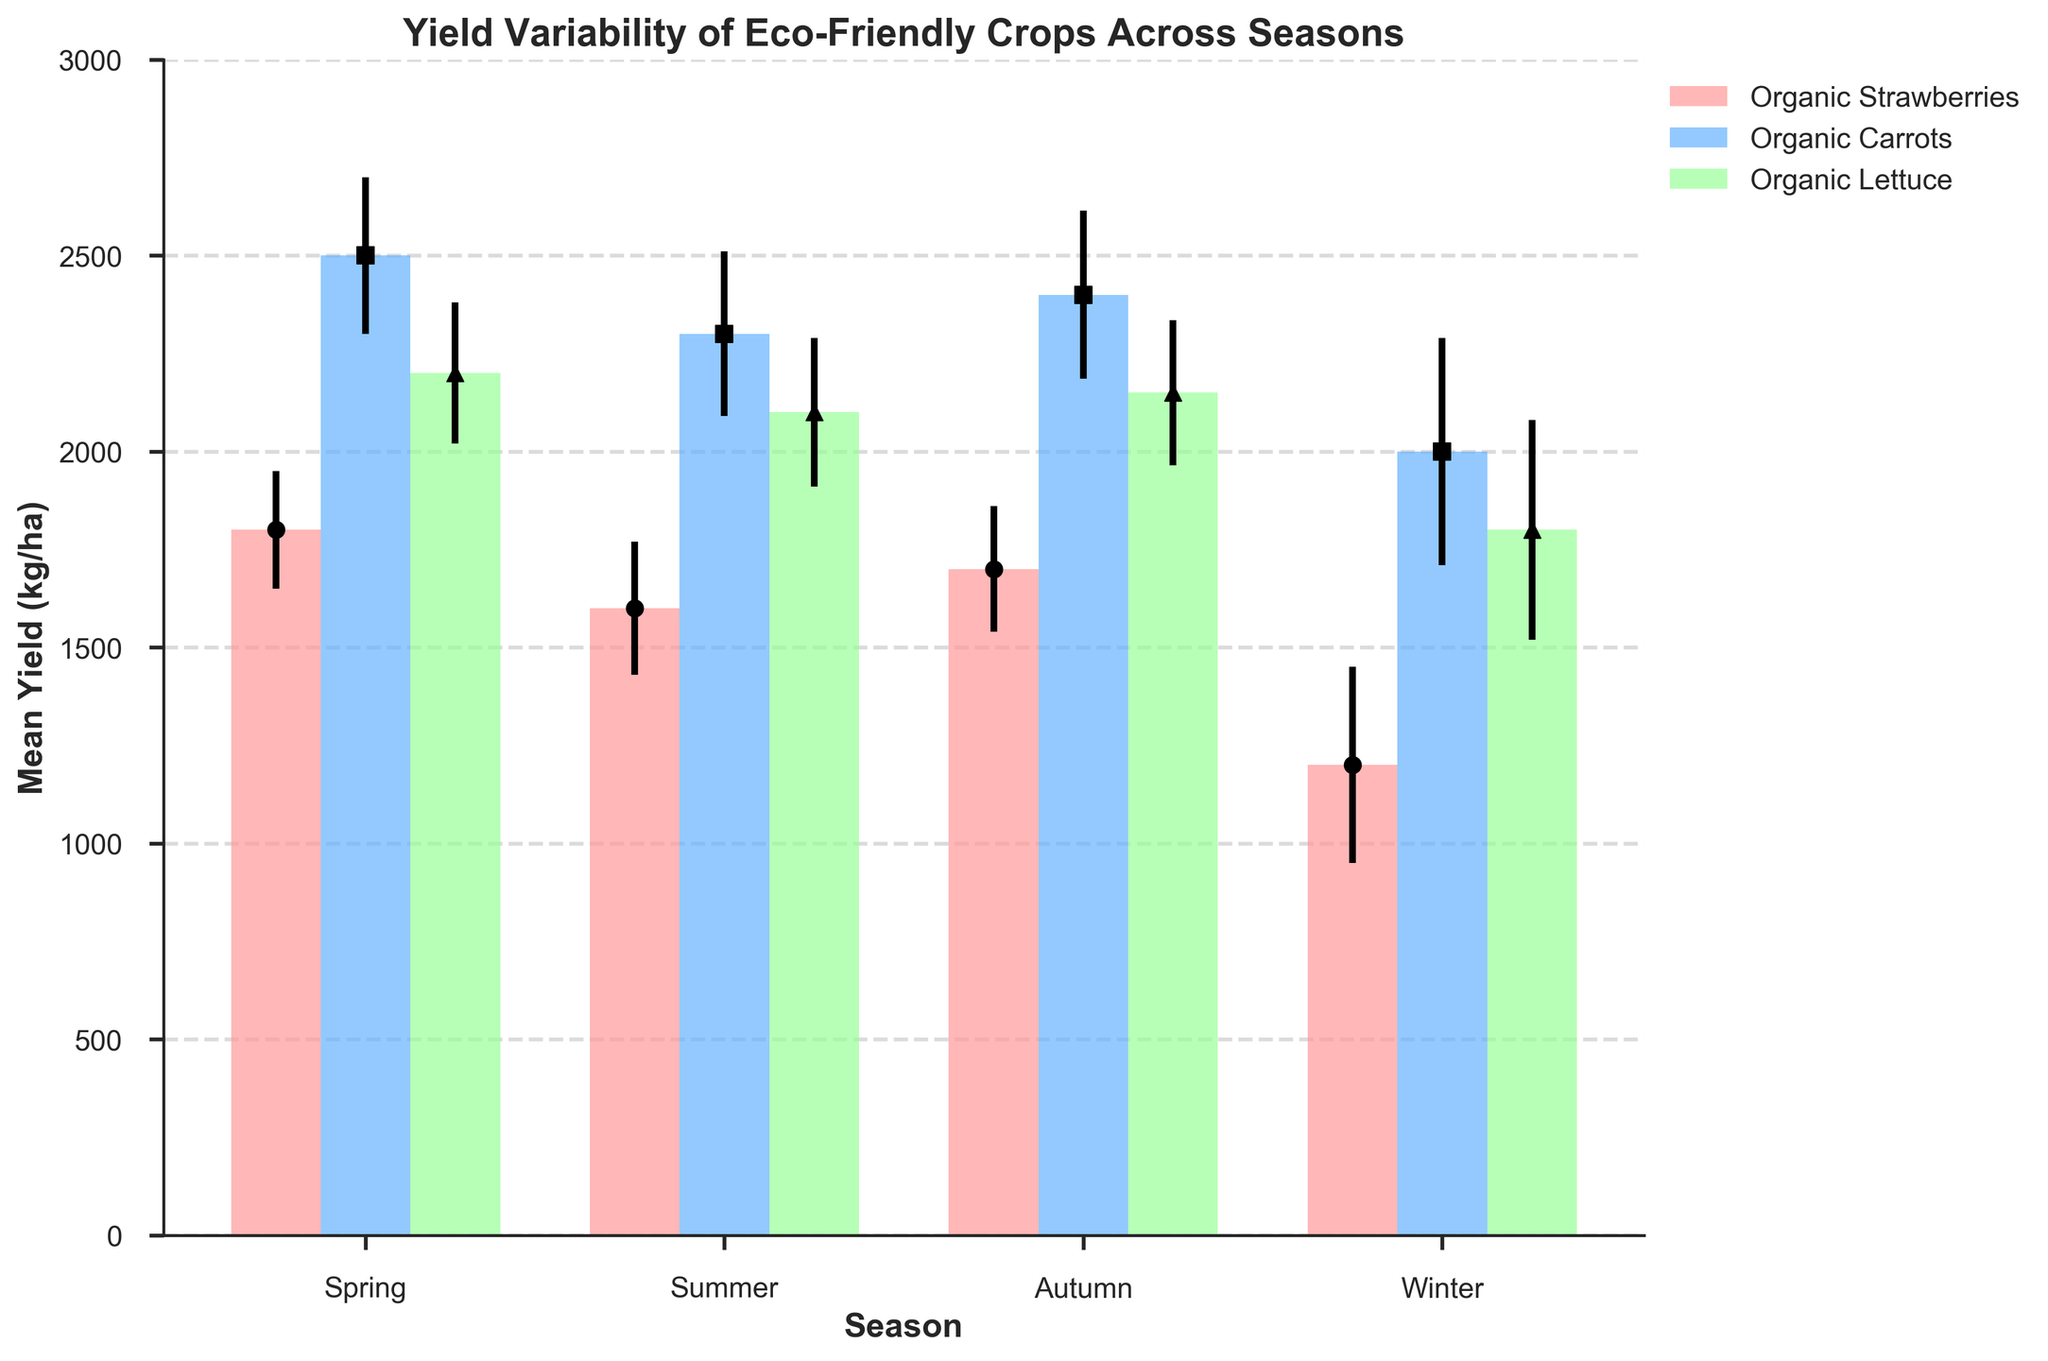What is the mean yield of Organic Strawberries in Spring? Locate the bar corresponding to Organic Strawberries for the Spring season and read the mean yield value shown on the y-axis. It is the height of the bar representing this crop in Spring.
Answer: 1800 kg/ha What crop has the highest yield in Summer? Compare the heights of the bars for each crop in Summer. The highest bar corresponds to the crop with the highest yield. Organic Carrots have the highest bar in Summer.
Answer: Organic Carrots Between which seasons does the yield of Organic Lettuce vary the most? Compare the heights of the bars for Organic Lettuce across all seasons. The biggest difference in bar height occurs between Winter (1800 kg/ha) and Spring (2200 kg/ha).
Answer: Winter and Spring What is the mean yield difference between Organic Carrots in Spring and Winter? Find the mean yield values for Organic Carrots in Spring and Winter, then subtract the Winter value from the Spring value: 2500 kg/ha (Spring) - 2000 kg/ha (Winter).
Answer: 500 kg/ha Which crop shows the most variability in yield across seasons based on error bars? Examine the error bars for each crop across all seasons. The crop with the largest and most varying error bars indicates the most variability in yield. Organic Carrots and Organic Lettuce have comparable variability, but Organic Carrots has slightly larger error bars overall.
Answer: Organic Carrots Does the mean yield of Organic Strawberries increase or decrease from Spring to Autumn? Compare the height of the bars representing Organic Strawberries in Spring and Autumn. The height decreases from Spring (1800 kg/ha) to Autumn (1700 kg/ha).
Answer: Decrease What is the standard deviation of Organic Lettuce yield in Winter? Locate the error bar for Organic Lettuce in Winter and read the value of the standard deviation. It is the length of the error bar. The standard deviation for Organic Lettuce in Winter is 280 kg/ha.
Answer: 280 kg/ha Which season has the smallest total mean yield for all crops combined? Sum the mean yields of all three crops in each season and compare the totals. Winter: (1200 + 2000 + 1800 = 5000 kg/ha). Spring: (1800 + 2500 + 2200 = 6500 kg/ha). Summer: (1600 + 2300 + 2100 = 6000 kg/ha). Autumn: (1700 + 2400 + 2150 = 6250 kg/ha). Winter has the smallest total mean yield.
Answer: Winter Is there any season where the mean yield of all three crops is above 2000 kg/ha? Check the mean yield values for each crop in every season. No season has all three crops with mean yields above 2000 kg/ha.
Answer: No How much does the mean yield of Organic Strawberries vary from Spring to Summer? Subtract the mean yield of Organic Strawberries in Summer from the yield in Spring: 1800 kg/ha (Spring) - 1600 kg/ha (Summer).
Answer: 200 kg/ha 